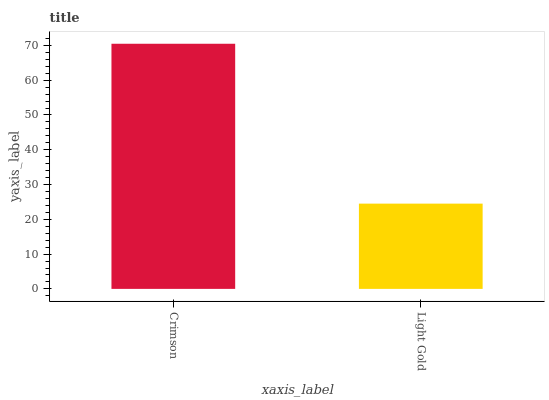Is Light Gold the minimum?
Answer yes or no. Yes. Is Crimson the maximum?
Answer yes or no. Yes. Is Light Gold the maximum?
Answer yes or no. No. Is Crimson greater than Light Gold?
Answer yes or no. Yes. Is Light Gold less than Crimson?
Answer yes or no. Yes. Is Light Gold greater than Crimson?
Answer yes or no. No. Is Crimson less than Light Gold?
Answer yes or no. No. Is Crimson the high median?
Answer yes or no. Yes. Is Light Gold the low median?
Answer yes or no. Yes. Is Light Gold the high median?
Answer yes or no. No. Is Crimson the low median?
Answer yes or no. No. 